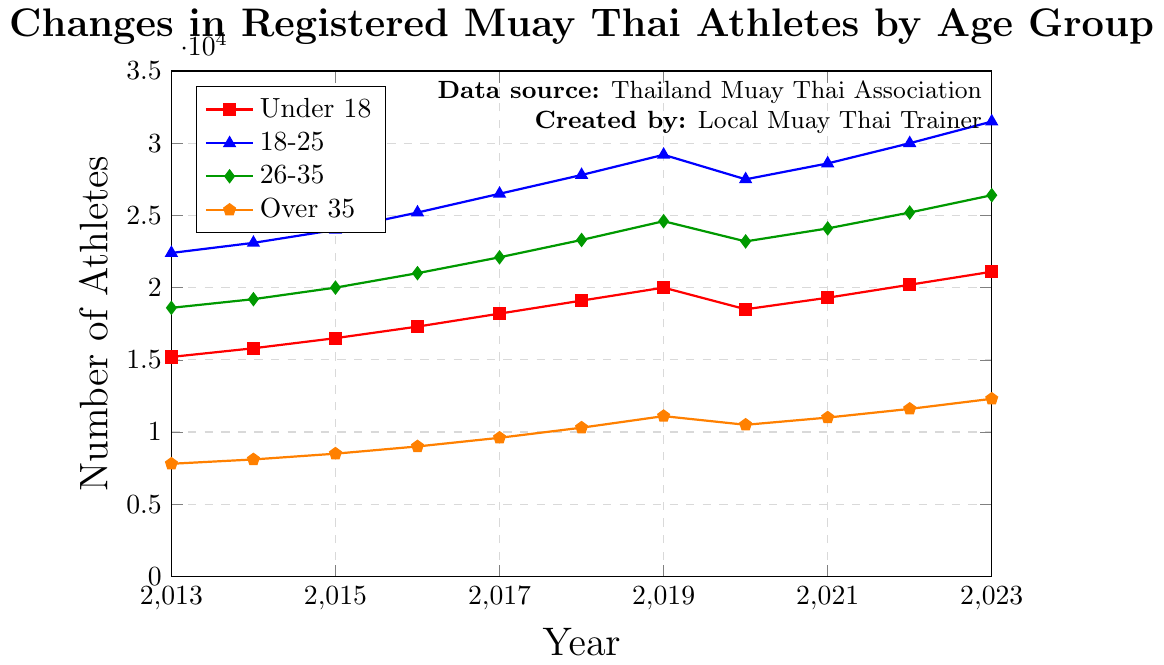Which age group saw the greatest overall increase in the number of athletes from 2013 to 2023? The increase in the number of athletes for each age group from 2013 to 2023 is calculated as follows:
- Under 18: 21100 - 15200 = 5900
- 18-25: 31500 - 22400 = 9100
- 26-35: 26400 - 18600 = 7800
- Over 35: 12300 - 7800 = 4500
The 18-25 age group saw the greatest increase.
Answer: 18-25 Which two age groups had a decline in the number of athletes between 2019 and 2020? By examining the data from 2019 to 2020:
- Under 18: 20000 to 18500 (decline)
- 18-25: 29200 to 27500 (decline)
- 26-35: 24600 to 23200 (decline)
- Over 35: 11100 to 10500 (decline)
All age groups experienced a decline, but the question asks for two.
Answer: Under 18 and 18-25 In 2023, what is the difference in the number of athletes between the age group 26-35 and Over 35? The number of athletes in 2023 for both groups:
- 26-35: 26400
- Over 35: 12300
The difference is: 26400 - 12300 = 14100.
Answer: 14100 Which age group consistently showed an increase in the number of athletes every year from 2013 to 2023? By examining each age group's data:
- Under 18: Decline from 2019 to 2020.
- 18-25: Decline from 2019 to 2020.
- 26-35: Decline from 2019 to 2020.
- Over 35: No decline in the entire period.
The Over 35 age group showed a consistent increase.
Answer: Over 35 What was the average number of athletes in the 18-25 age group over the decade? Sum the number of athletes for each year from 2013 to 2023 and divide by 11:
(22400 + 23100 + 24000 + 25200 + 26500 + 27800 + 29200 + 27500 + 28600 + 30000 + 31500) / 11 = 26500
Answer: 26500 From 2013 to 2023, which year did the Under 18 age group see the highest increase in athletes compared to the previous year? Calculate the year-to-year increase:
- 2013-2014: 15800 - 15200 = 600
- 2014-2015: 16500 - 15800 = 700
- 2015-2016: 17300 - 16500 = 800
- 2016-2017: 18200 - 17300 = 900
- 2017-2018: 19100 - 18200 = 900
- 2018-2019: 20000 - 19100 = 900
- 2019-2020: 18500 - 20000 = (-1500)
- 2020-2021: 19300 - 18500 = 800
- 2021-2022: 20200 - 19300 = 900
- 2022-2023: 21100 - 20200 = 900
Simplifying the information, each annual increase displays no single highest change; instead, multiple years (2016-2017, 2017-2018, 2018-2019, 2021-2022, and 2022-2023) share the highest increase of 900 athletes.
Answer: 900 Which age group had the smallest number of registered athletes in 2016? Compare the number of athletes in 2016:
- Under 18: 17300
- 18-25: 25200
- 26-35: 21000
- Over 35: 9000
The Over 35 age group had the smallest number.
Answer: Over 35 How many athletes in total were registered across all age groups in 2023? Sum the number of athletes in each age group in 2023:
21100 (Under 18) + 31500 (18-25) + 26400 (26-35) + 12300 (Over 35) = 91300
Answer: 91300 Comparing the figures in 2021, how many more athletes were registered in the age group 26-35 than in the age group Under 18? Subtract the number of Under 18 athletes in 2021 from the number of 26-35 athletes:
24100 - 19300 = 4800
Answer: 4800 